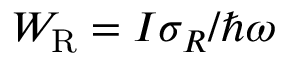Convert formula to latex. <formula><loc_0><loc_0><loc_500><loc_500>W _ { R } = I \sigma _ { R } / \hbar { \omega }</formula> 